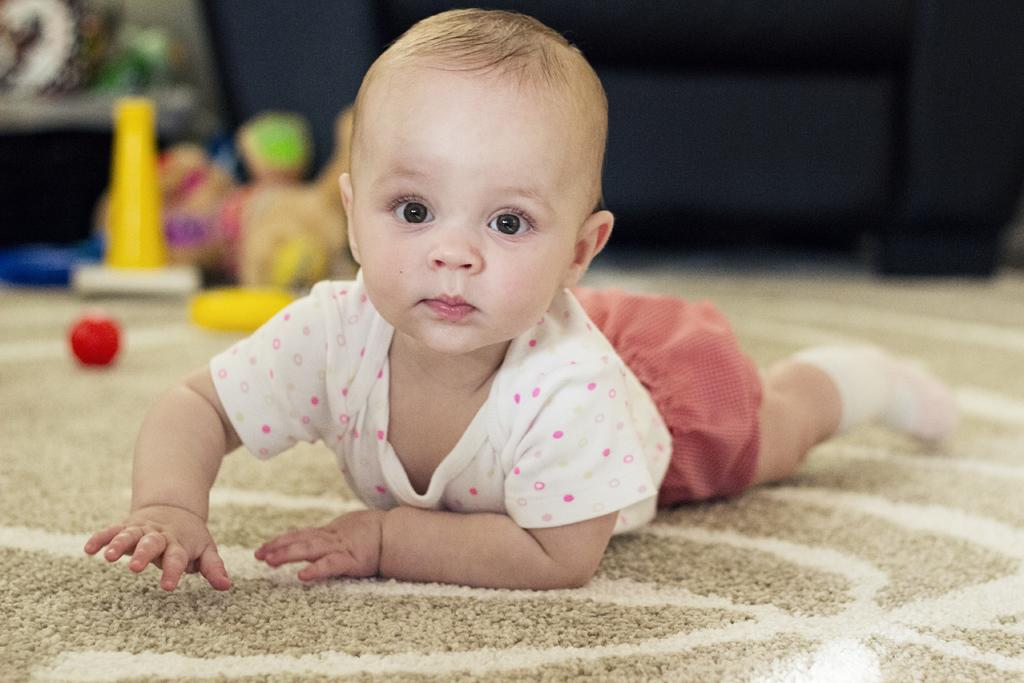What is the main subject of the image? The main subject of the image is a baby. What is the baby doing in the image? The baby is lying on the floor. What type of clothing is the baby wearing? The baby is wearing a t-shirt and shorts. How many clocks can be seen hanging on the wall behind the baby in the image? There are no clocks visible in the image. What type of animal is sitting next to the baby in the image? There is no animal present in the image; it only features the baby. 